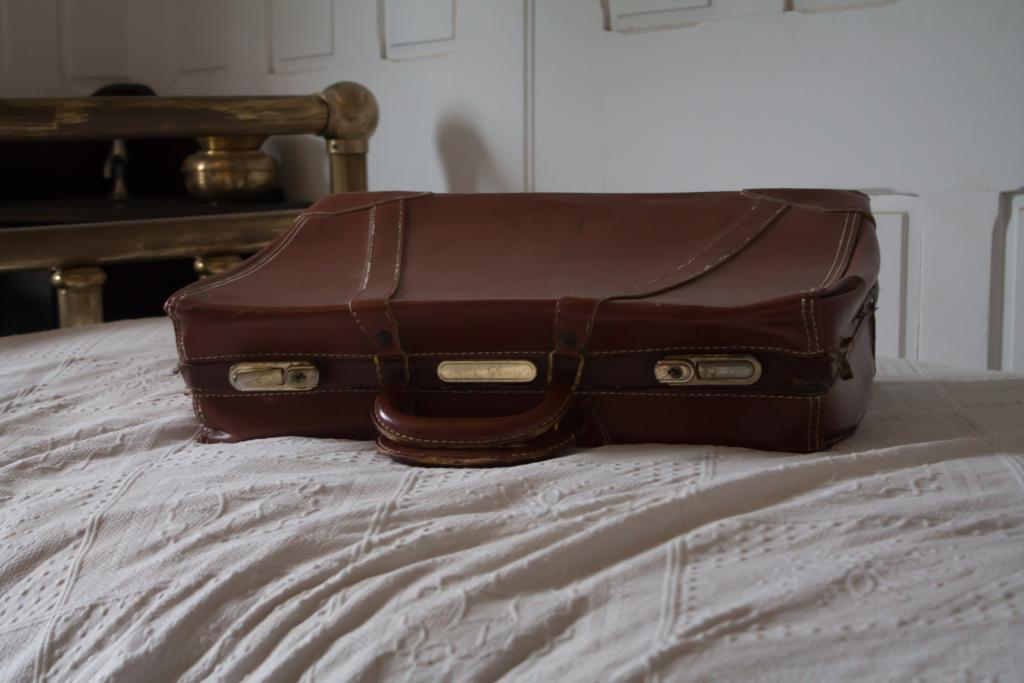What color is the suitcase in the image? The suitcase in the image is brown. Where is the brown suitcase located? The brown suitcase is on a white bed. What type of apparel is the police officer wearing in the image? There is no police officer or apparel present in the image; it only features a brown suitcase on a white bed. 